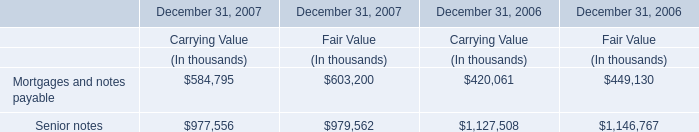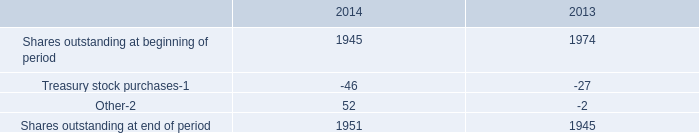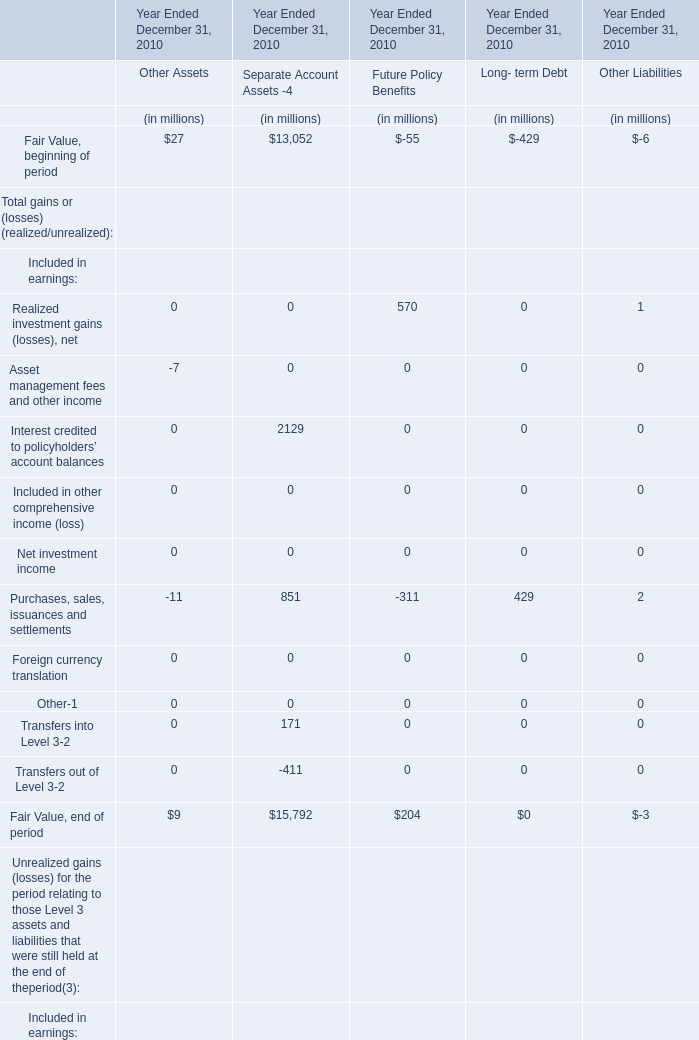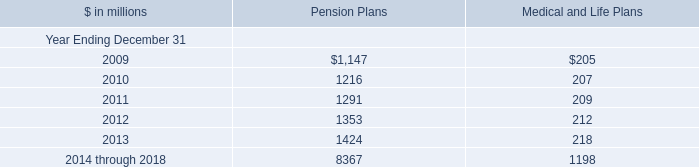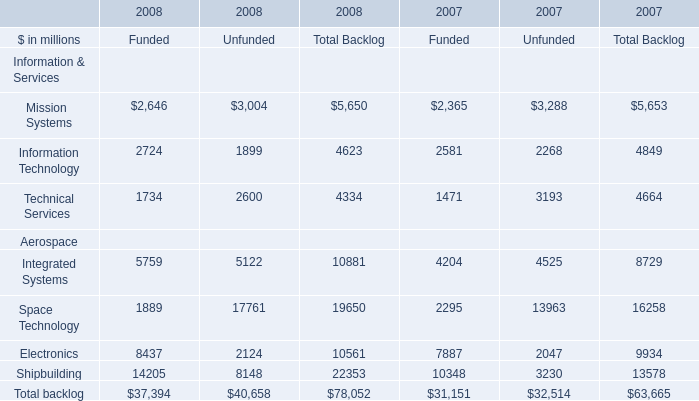What's the average of Shares outstanding at end of period of 2013, and Electronics Aerospace of 2007 Unfunded ? 
Computations: ((1945.0 + 2047.0) / 2)
Answer: 1996.0. 